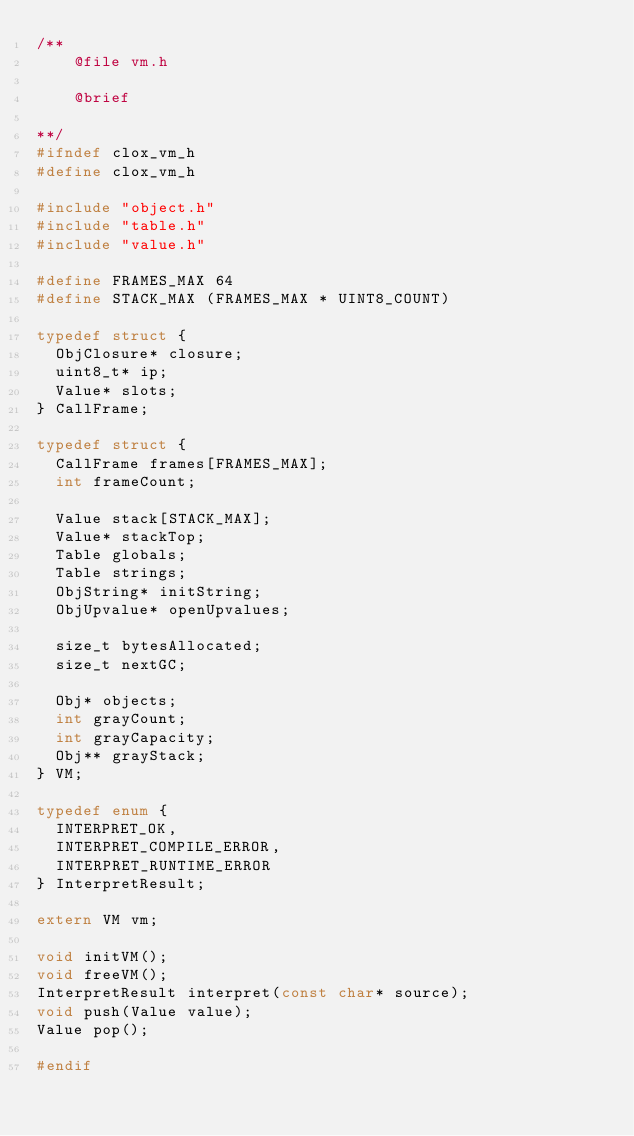Convert code to text. <code><loc_0><loc_0><loc_500><loc_500><_C_>/**
    @file vm.h

    @brief

**/
#ifndef clox_vm_h
#define clox_vm_h

#include "object.h"
#include "table.h"
#include "value.h"

#define FRAMES_MAX 64
#define STACK_MAX (FRAMES_MAX * UINT8_COUNT)

typedef struct {
  ObjClosure* closure;
  uint8_t* ip;
  Value* slots;
} CallFrame;

typedef struct {
  CallFrame frames[FRAMES_MAX];
  int frameCount;

  Value stack[STACK_MAX];
  Value* stackTop;
  Table globals;
  Table strings;
  ObjString* initString;
  ObjUpvalue* openUpvalues;

  size_t bytesAllocated;
  size_t nextGC;

  Obj* objects;
  int grayCount;
  int grayCapacity;
  Obj** grayStack;
} VM;

typedef enum {
  INTERPRET_OK,
  INTERPRET_COMPILE_ERROR,
  INTERPRET_RUNTIME_ERROR
} InterpretResult;

extern VM vm;

void initVM();
void freeVM();
InterpretResult interpret(const char* source);
void push(Value value);
Value pop();

#endif
</code> 